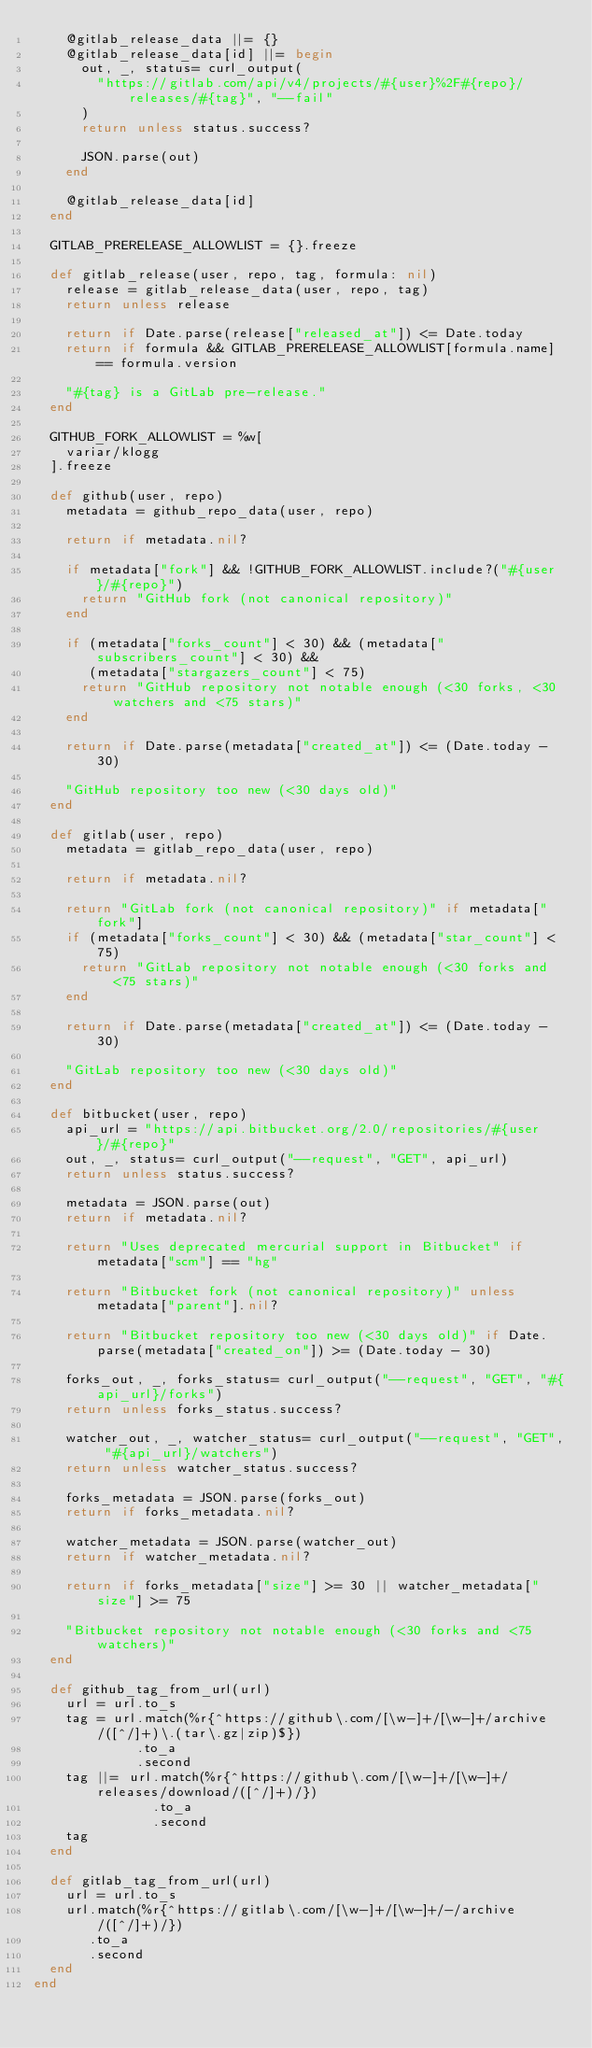Convert code to text. <code><loc_0><loc_0><loc_500><loc_500><_Ruby_>    @gitlab_release_data ||= {}
    @gitlab_release_data[id] ||= begin
      out, _, status= curl_output(
        "https://gitlab.com/api/v4/projects/#{user}%2F#{repo}/releases/#{tag}", "--fail"
      )
      return unless status.success?

      JSON.parse(out)
    end

    @gitlab_release_data[id]
  end

  GITLAB_PRERELEASE_ALLOWLIST = {}.freeze

  def gitlab_release(user, repo, tag, formula: nil)
    release = gitlab_release_data(user, repo, tag)
    return unless release

    return if Date.parse(release["released_at"]) <= Date.today
    return if formula && GITLAB_PRERELEASE_ALLOWLIST[formula.name] == formula.version

    "#{tag} is a GitLab pre-release."
  end

  GITHUB_FORK_ALLOWLIST = %w[
    variar/klogg
  ].freeze

  def github(user, repo)
    metadata = github_repo_data(user, repo)

    return if metadata.nil?

    if metadata["fork"] && !GITHUB_FORK_ALLOWLIST.include?("#{user}/#{repo}")
      return "GitHub fork (not canonical repository)"
    end

    if (metadata["forks_count"] < 30) && (metadata["subscribers_count"] < 30) &&
       (metadata["stargazers_count"] < 75)
      return "GitHub repository not notable enough (<30 forks, <30 watchers and <75 stars)"
    end

    return if Date.parse(metadata["created_at"]) <= (Date.today - 30)

    "GitHub repository too new (<30 days old)"
  end

  def gitlab(user, repo)
    metadata = gitlab_repo_data(user, repo)

    return if metadata.nil?

    return "GitLab fork (not canonical repository)" if metadata["fork"]
    if (metadata["forks_count"] < 30) && (metadata["star_count"] < 75)
      return "GitLab repository not notable enough (<30 forks and <75 stars)"
    end

    return if Date.parse(metadata["created_at"]) <= (Date.today - 30)

    "GitLab repository too new (<30 days old)"
  end

  def bitbucket(user, repo)
    api_url = "https://api.bitbucket.org/2.0/repositories/#{user}/#{repo}"
    out, _, status= curl_output("--request", "GET", api_url)
    return unless status.success?

    metadata = JSON.parse(out)
    return if metadata.nil?

    return "Uses deprecated mercurial support in Bitbucket" if metadata["scm"] == "hg"

    return "Bitbucket fork (not canonical repository)" unless metadata["parent"].nil?

    return "Bitbucket repository too new (<30 days old)" if Date.parse(metadata["created_on"]) >= (Date.today - 30)

    forks_out, _, forks_status= curl_output("--request", "GET", "#{api_url}/forks")
    return unless forks_status.success?

    watcher_out, _, watcher_status= curl_output("--request", "GET", "#{api_url}/watchers")
    return unless watcher_status.success?

    forks_metadata = JSON.parse(forks_out)
    return if forks_metadata.nil?

    watcher_metadata = JSON.parse(watcher_out)
    return if watcher_metadata.nil?

    return if forks_metadata["size"] >= 30 || watcher_metadata["size"] >= 75

    "Bitbucket repository not notable enough (<30 forks and <75 watchers)"
  end

  def github_tag_from_url(url)
    url = url.to_s
    tag = url.match(%r{^https://github\.com/[\w-]+/[\w-]+/archive/([^/]+)\.(tar\.gz|zip)$})
             .to_a
             .second
    tag ||= url.match(%r{^https://github\.com/[\w-]+/[\w-]+/releases/download/([^/]+)/})
               .to_a
               .second
    tag
  end

  def gitlab_tag_from_url(url)
    url = url.to_s
    url.match(%r{^https://gitlab\.com/[\w-]+/[\w-]+/-/archive/([^/]+)/})
       .to_a
       .second
  end
end
</code> 